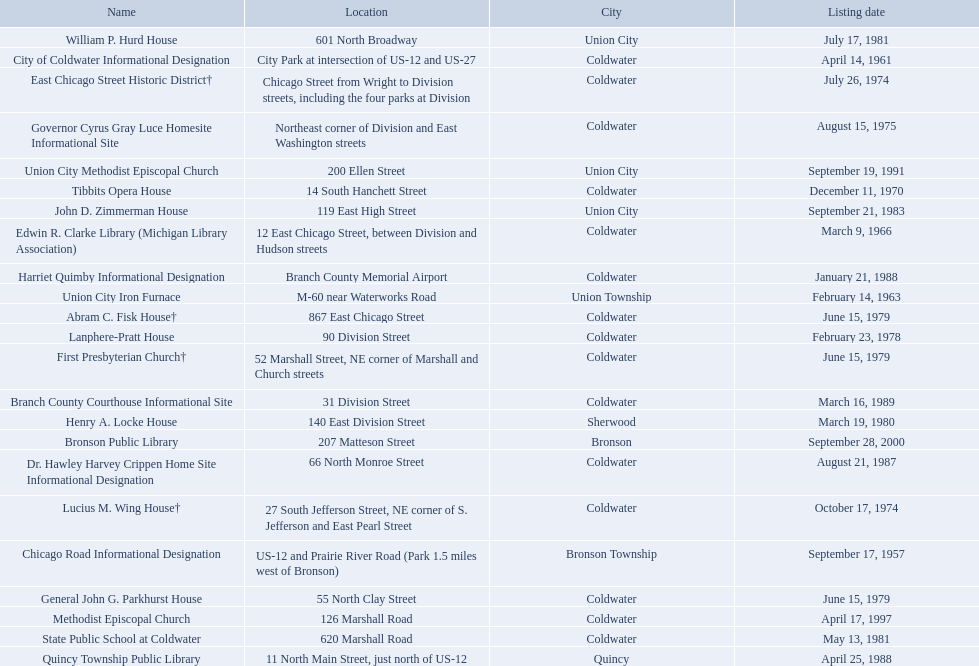What are all of the locations considered historical sites in branch county, michigan? Branch County Courthouse Informational Site, Bronson Public Library, Chicago Road Informational Designation, City of Coldwater Informational Designation, Edwin R. Clarke Library (Michigan Library Association), Dr. Hawley Harvey Crippen Home Site Informational Designation, East Chicago Street Historic District†, First Presbyterian Church†, Abram C. Fisk House†, William P. Hurd House, Lanphere-Pratt House, Henry A. Locke House, Governor Cyrus Gray Luce Homesite Informational Site, Methodist Episcopal Church, General John G. Parkhurst House, Harriet Quimby Informational Designation, Quincy Township Public Library, State Public School at Coldwater, Tibbits Opera House, Union City Iron Furnace, Union City Methodist Episcopal Church, Lucius M. Wing House†, John D. Zimmerman House. Of those sites, which one was the first to be listed as historical? Chicago Road Informational Designation. 